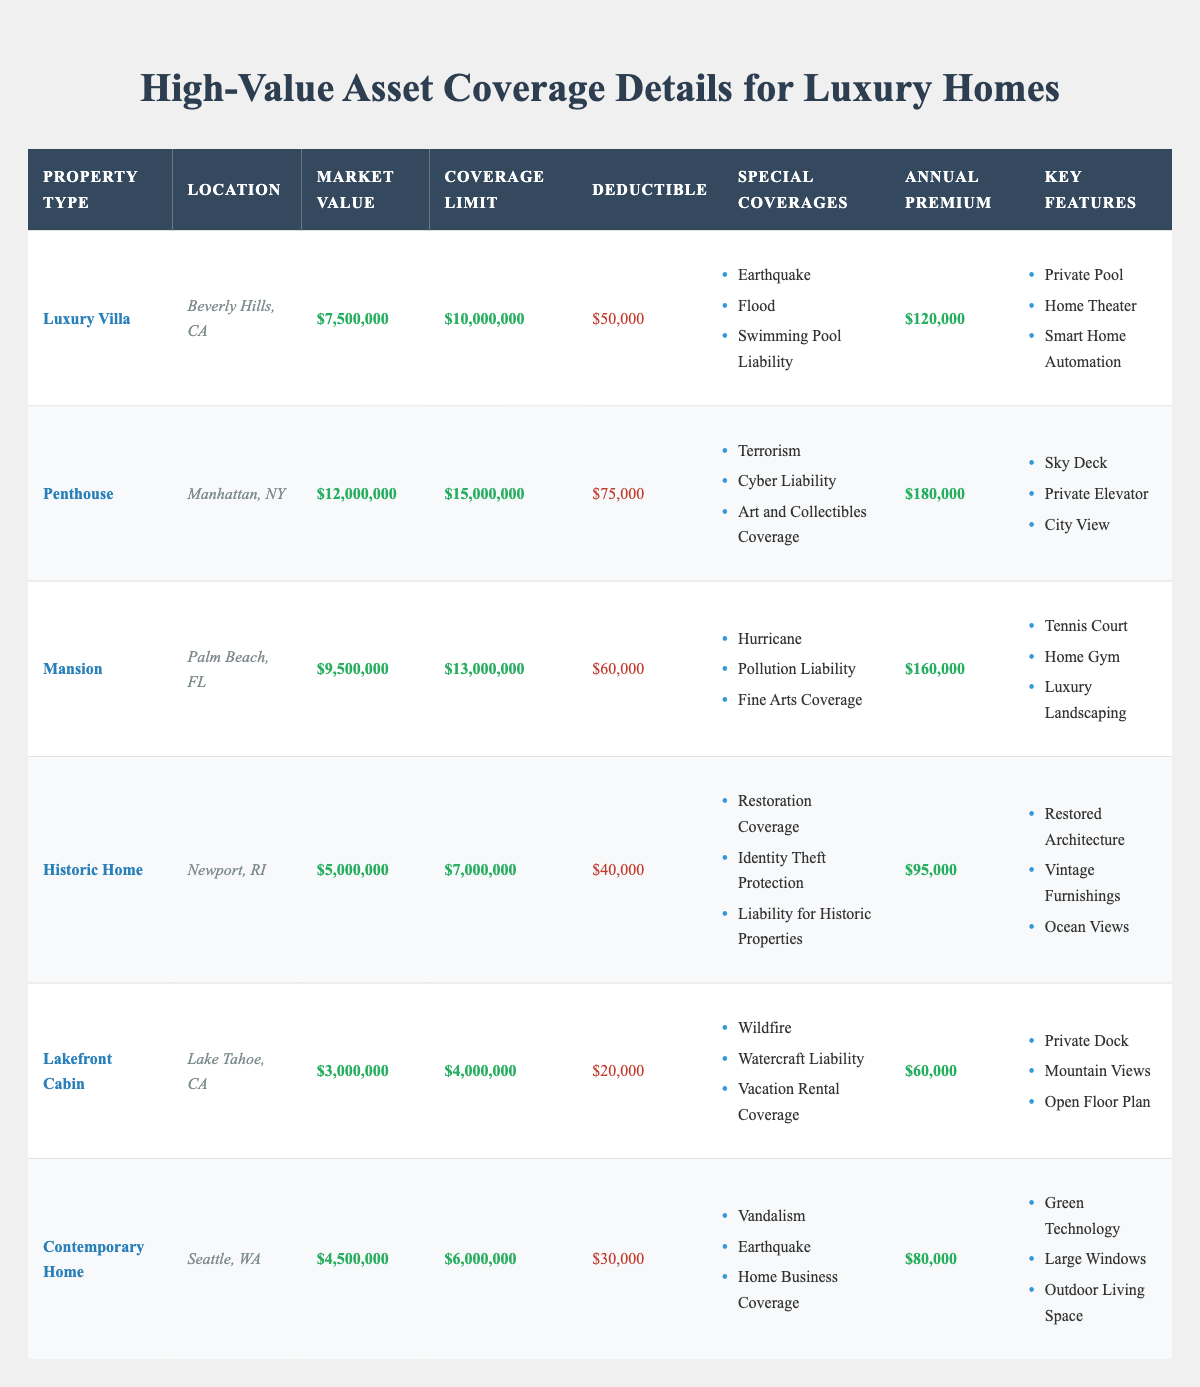What is the coverage limit for the Penthouse in Manhattan, NY? The table lists the Penthouse under the 'Property Type' column with its corresponding 'Coverage Limit' value, which is $15,000,000.
Answer: $15,000,000 What is the deductible for the Luxury Villa? The Luxury Villa's deductible can be found in the same row under the 'Deductible' column, which is $50,000.
Answer: $50,000 Which property has the highest annual premium? By comparing the 'Annual Premium' values across the properties, the Penthouse has the highest premium at $180,000, which is more than any other listed property.
Answer: Penthouse True or False: The Historic Home has a Market Value greater than $6,000,000. By referencing the 'Market Value' for the Historic Home, listed at $5,000,000, it is evident that this value is less than $6,000,000, making the statement false.
Answer: False What is the average market value of all the properties listed? To calculate the average market value, first sum all market values: $7,500,000 + $12,000,000 + $9,500,000 + $5,000,000 + $3,000,000 + $4,500,000 = $41,500,000. Then divide by the number of properties (6): $41,500,000 / 6 = approximately $6,916,667.
Answer: $6,916,667 Which special coverage is included in the Mansion insurance policy? The table indicates that the Mansion includes 'Hurricane', 'Pollution Liability', and 'Fine Arts Coverage' under the 'Special Coverages' column.
Answer: Hurricane, Pollution Liability, Fine Arts Coverage What is the total coverage limit for properties located in California? For properties in California, the Luxury Villa has a coverage limit of $10,000,000 and the Lakefront Cabin has a limit of $4,000,000. The total coverage is $10,000,000 + $4,000,000 = $14,000,000.
Answer: $14,000,000 Does the Contemporary Home offer coverage for vandalism? According to the table, the 'Special Coverages' for the Contemporary Home includes 'Vandalism'. Therefore, the statement is true.
Answer: True What is the difference in annual premium between the Mansion and the Lakefront Cabin? The annual premium for the Mansion is $160,000 and for the Lakefront Cabin, it is $60,000. The difference is $160,000 - $60,000 = $100,000.
Answer: $100,000 